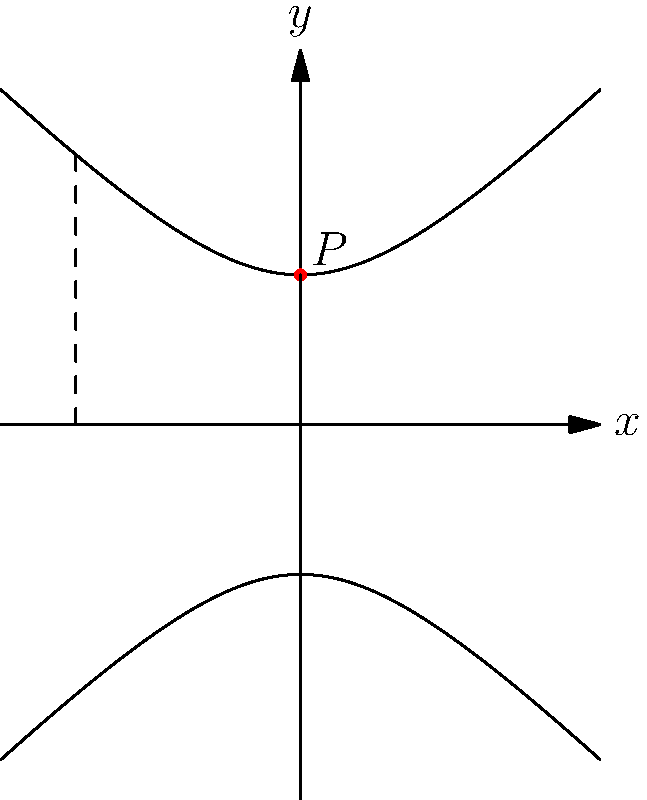As a meteorologist familiar with modeling complex atmospheric systems, consider the hyperbolic plane model shown above to represent the curvature of space-time near a black hole. If point $P$ represents an observer's position, what is the distance between $P$ and the $x$-axis according to the hyperbolic metric $ds^2 = dx^2 + e^{-2y}dy^2$? To solve this problem, we'll follow these steps:

1) In the hyperbolic plane model, the curves represent lines of constant $x$ coordinate. The point $P$ is on the $y$-axis, so its $x$ coordinate is 0.

2) The $y$ coordinate of $P$ is 1 in the Euclidean plane, but we need to find its hyperbolic distance from the $x$-axis.

3) The hyperbolic metric is given by $ds^2 = dx^2 + e^{-2y}dy^2$. Since we're moving along the $y$-axis, $dx = 0$, so we only need to consider $ds^2 = e^{-2y}dy^2$.

4) To find the distance, we need to integrate:

   $$d = \int_0^1 \sqrt{e^{-2y}} dy = \int_0^1 e^{-y} dy$$

5) Solving this integral:
   
   $$d = [-e^{-y}]_0^1 = -e^{-1} - (-e^0) = 1 - \frac{1}{e}$$

6) This can be simplified to:

   $$d = \frac{e-1}{e} \approx 0.632$$

This result shows that distances in the hyperbolic plane are shorter than in the Euclidean plane, reflecting the curvature of space-time near a black hole.
Answer: $\frac{e-1}{e}$ 